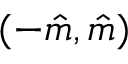<formula> <loc_0><loc_0><loc_500><loc_500>( - \hat { m } , \hat { m } )</formula> 